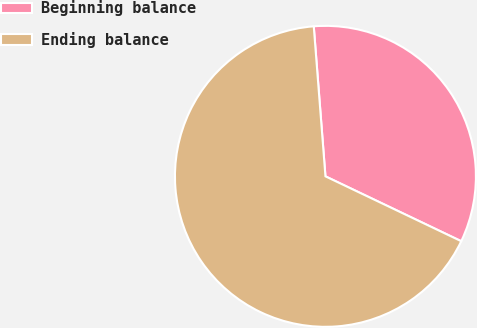Convert chart. <chart><loc_0><loc_0><loc_500><loc_500><pie_chart><fcel>Beginning balance<fcel>Ending balance<nl><fcel>33.33%<fcel>66.67%<nl></chart> 